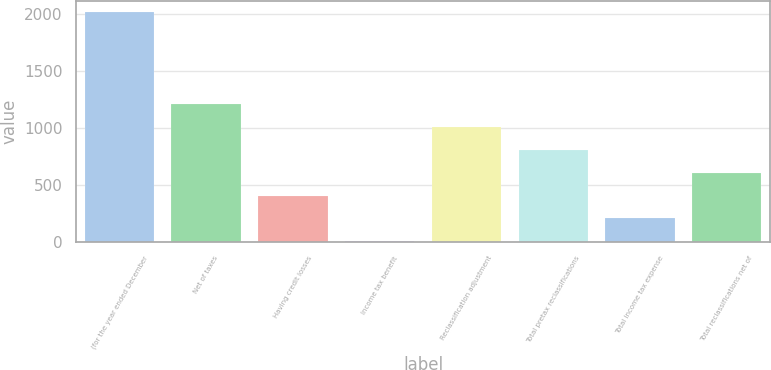Convert chart to OTSL. <chart><loc_0><loc_0><loc_500><loc_500><bar_chart><fcel>(for the year ended December<fcel>Net of taxes<fcel>Having credit losses<fcel>Income tax benefit<fcel>Reclassification adjustment<fcel>Total pretax reclassifications<fcel>Total income tax expense<fcel>Total reclassifications net of<nl><fcel>2011<fcel>1209<fcel>407<fcel>6<fcel>1008.5<fcel>808<fcel>206.5<fcel>607.5<nl></chart> 